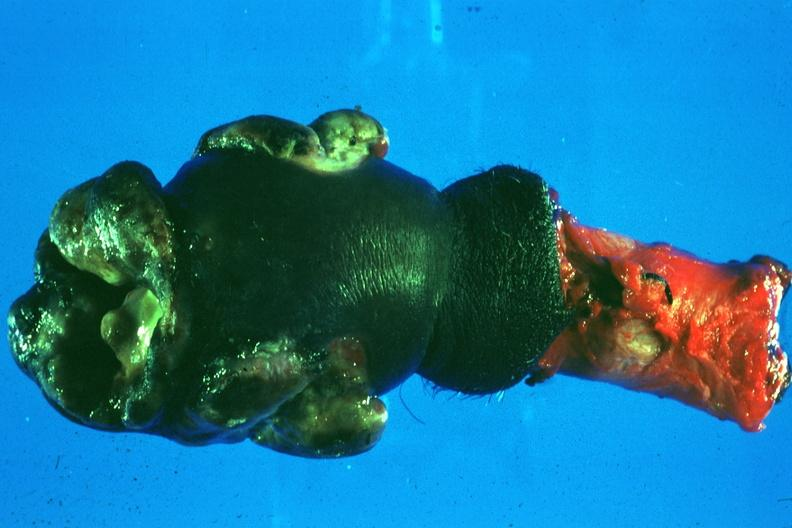what is present?
Answer the question using a single word or phrase. Penis 